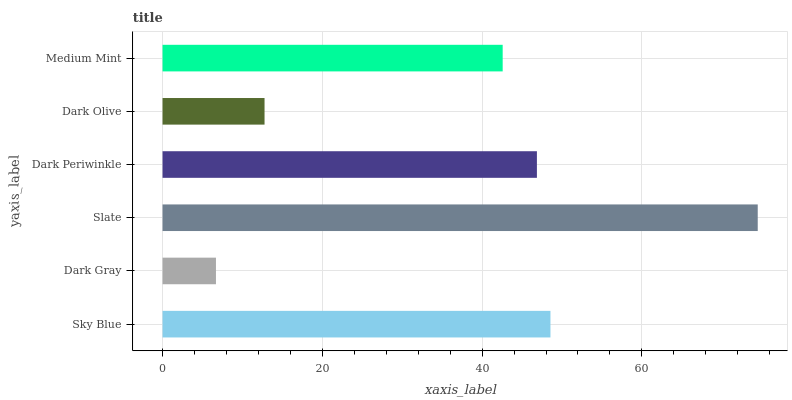Is Dark Gray the minimum?
Answer yes or no. Yes. Is Slate the maximum?
Answer yes or no. Yes. Is Slate the minimum?
Answer yes or no. No. Is Dark Gray the maximum?
Answer yes or no. No. Is Slate greater than Dark Gray?
Answer yes or no. Yes. Is Dark Gray less than Slate?
Answer yes or no. Yes. Is Dark Gray greater than Slate?
Answer yes or no. No. Is Slate less than Dark Gray?
Answer yes or no. No. Is Dark Periwinkle the high median?
Answer yes or no. Yes. Is Medium Mint the low median?
Answer yes or no. Yes. Is Sky Blue the high median?
Answer yes or no. No. Is Slate the low median?
Answer yes or no. No. 